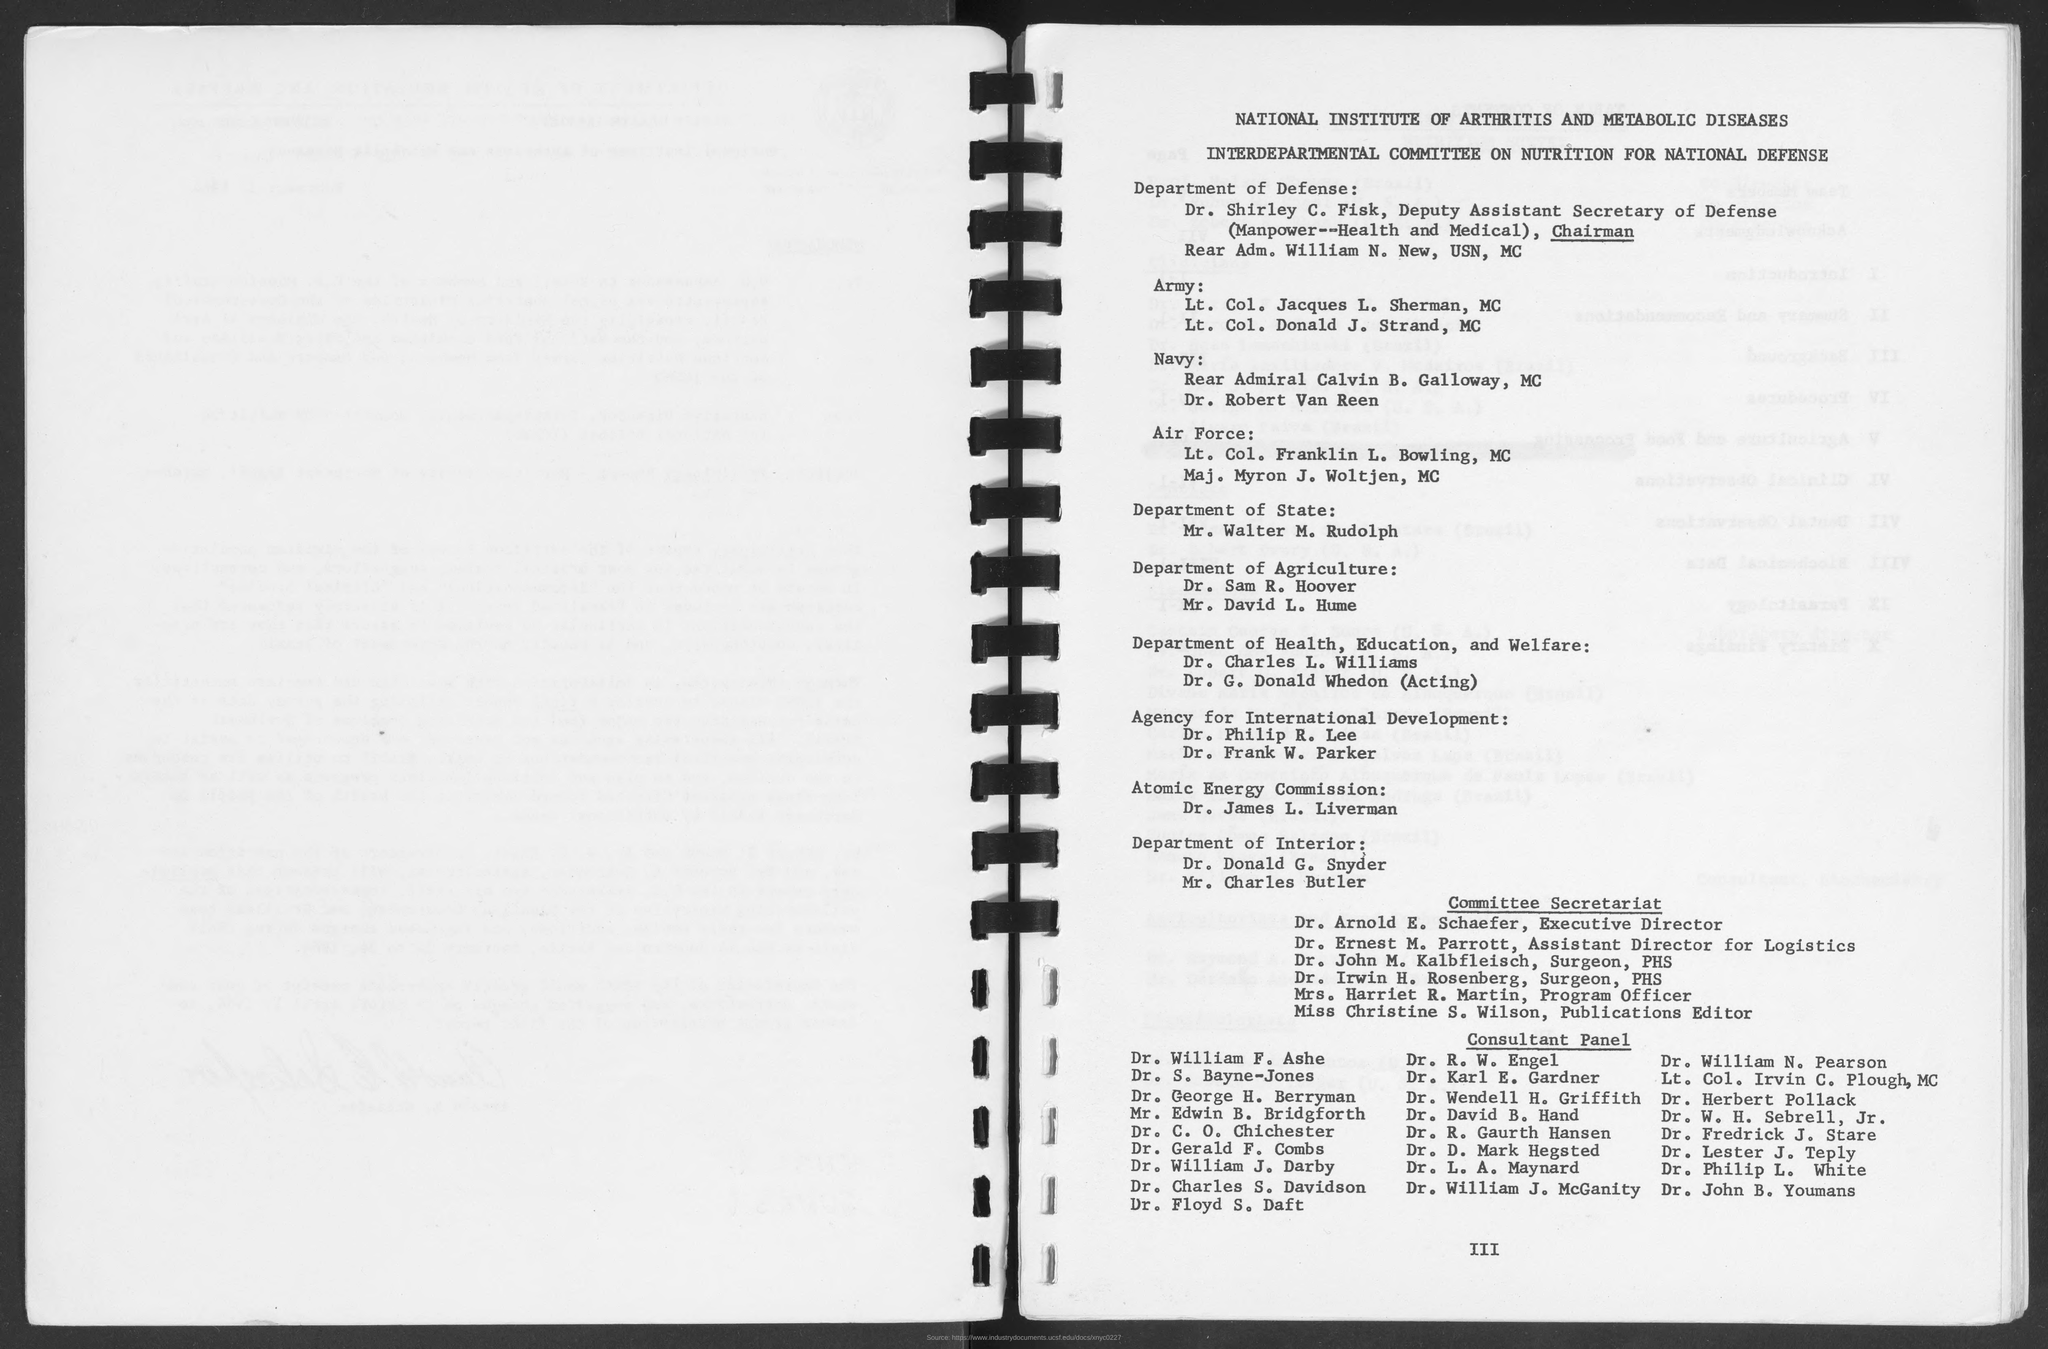To which department dr. sam r. hoover belongs to as mentioned in the given form ?
Provide a short and direct response. DEPARTMENT OF AGRICULTURE. To which department mr.walter m. rudolph belongs to as mentioned in the given page ?
Ensure brevity in your answer.  Department of state. To which department mr. charles butler  belongs to as mentioned in the given page ?
Your answer should be compact. DEPARTMENT OF INTERIOR. 